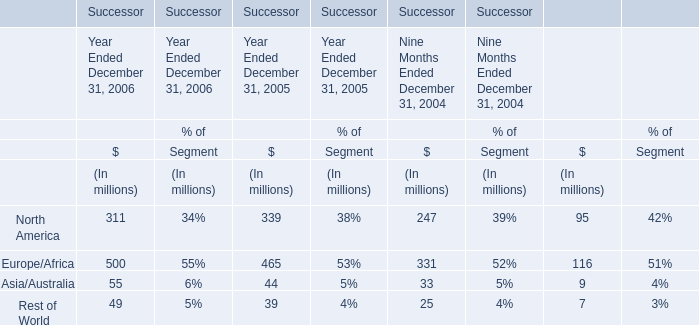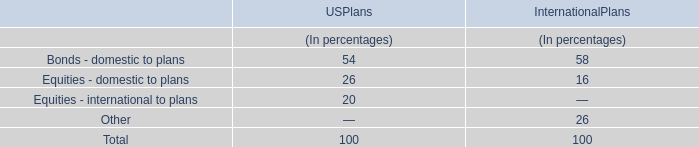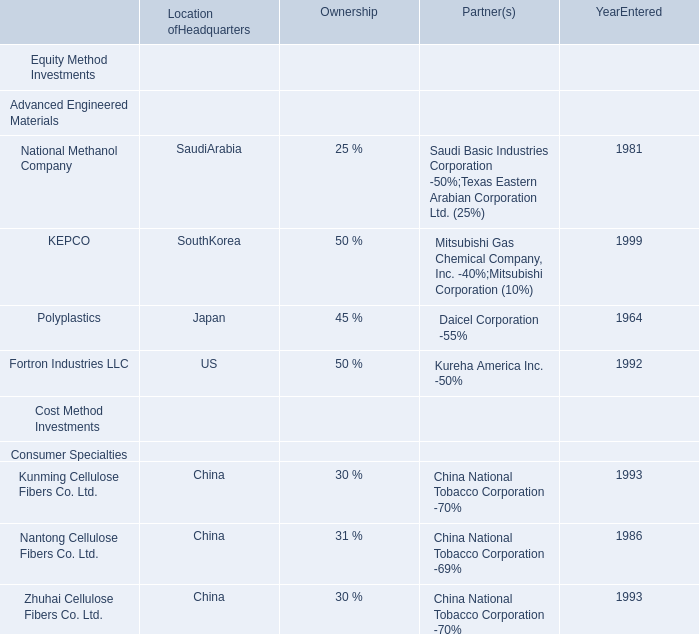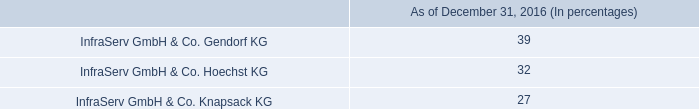What is the growing rate of Europe/Africa Sales in the year with the most Europe/Africa Sales? 
Computations: ((500 - 465) / 465)
Answer: 0.07527. 